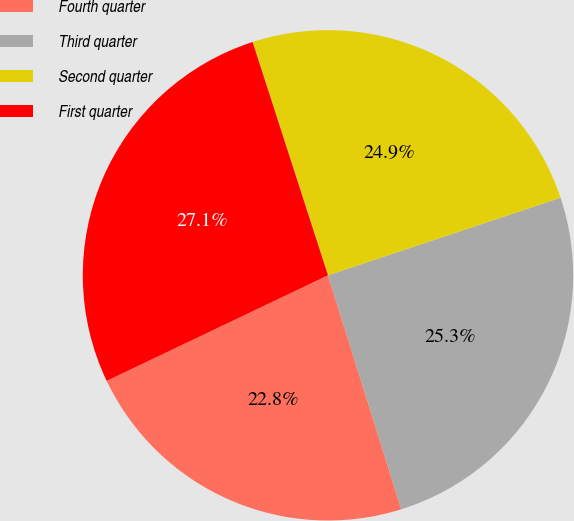<chart> <loc_0><loc_0><loc_500><loc_500><pie_chart><fcel>Fourth quarter<fcel>Third quarter<fcel>Second quarter<fcel>First quarter<nl><fcel>22.75%<fcel>25.29%<fcel>24.85%<fcel>27.11%<nl></chart> 